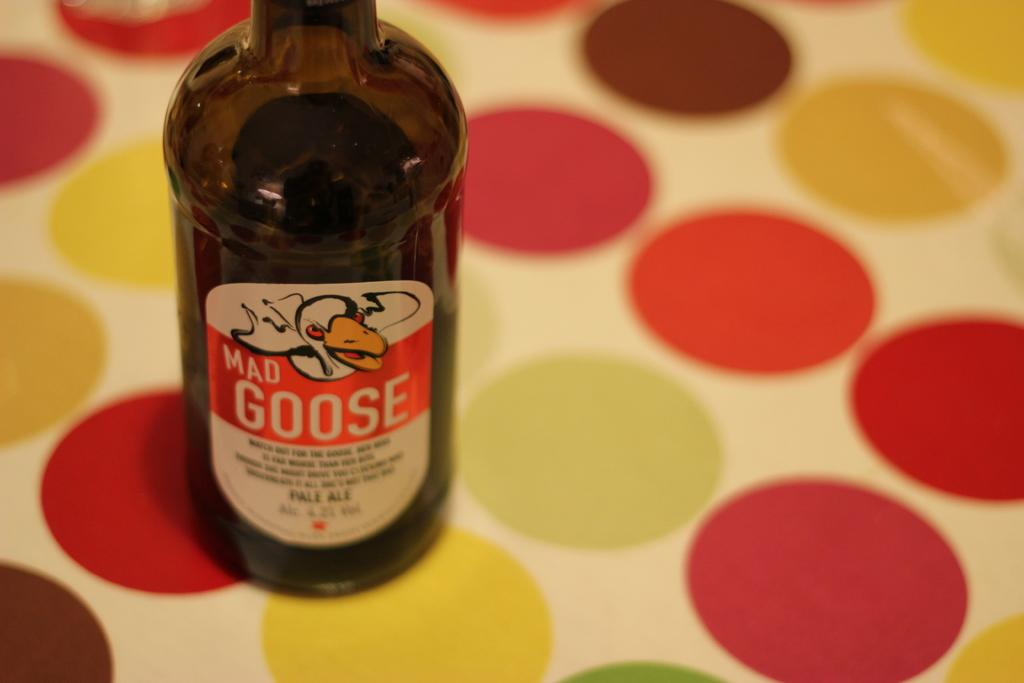<image>
Present a compact description of the photo's key features. A bottle of mad goose that is alcoholic in sense 